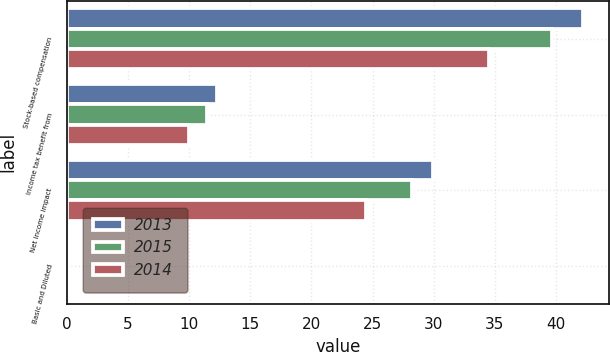Convert chart. <chart><loc_0><loc_0><loc_500><loc_500><stacked_bar_chart><ecel><fcel>Stock-based compensation<fcel>Income tax benefit from<fcel>Net income impact<fcel>Basic and Diluted<nl><fcel>2013<fcel>42.2<fcel>12.3<fcel>29.9<fcel>0.06<nl><fcel>2015<fcel>39.7<fcel>11.5<fcel>28.2<fcel>0.05<nl><fcel>2014<fcel>34.5<fcel>10<fcel>24.5<fcel>0.04<nl></chart> 